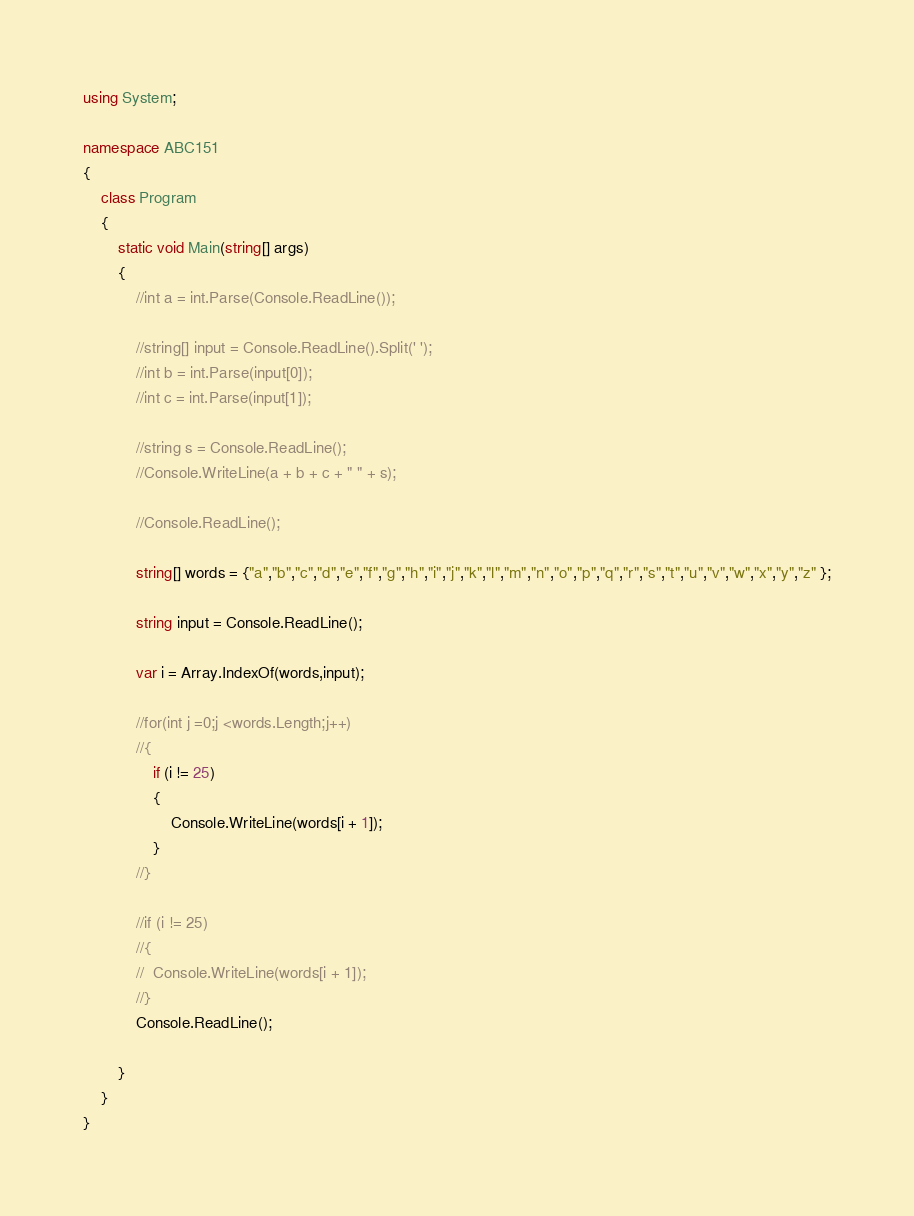Convert code to text. <code><loc_0><loc_0><loc_500><loc_500><_C#_>using System;

namespace ABC151
{
	class Program
	{
		static void Main(string[] args)
		{
			//int a = int.Parse(Console.ReadLine());

			//string[] input = Console.ReadLine().Split(' ');
			//int b = int.Parse(input[0]);
			//int c = int.Parse(input[1]);

			//string s = Console.ReadLine();
			//Console.WriteLine(a + b + c + " " + s);

			//Console.ReadLine();

			string[] words = {"a","b","c","d","e","f","g","h","i","j","k","l","m","n","o","p","q","r","s","t","u","v","w","x","y","z" };

			string input = Console.ReadLine();

			var i = Array.IndexOf(words,input);

			//for(int j =0;j <words.Length;j++)
			//{
				if (i != 25)
				{
					Console.WriteLine(words[i + 1]);
				}
			//}

			//if (i != 25)
			//{
			//	Console.WriteLine(words[i + 1]);
			//}
			Console.ReadLine();

		}
	}
}
</code> 